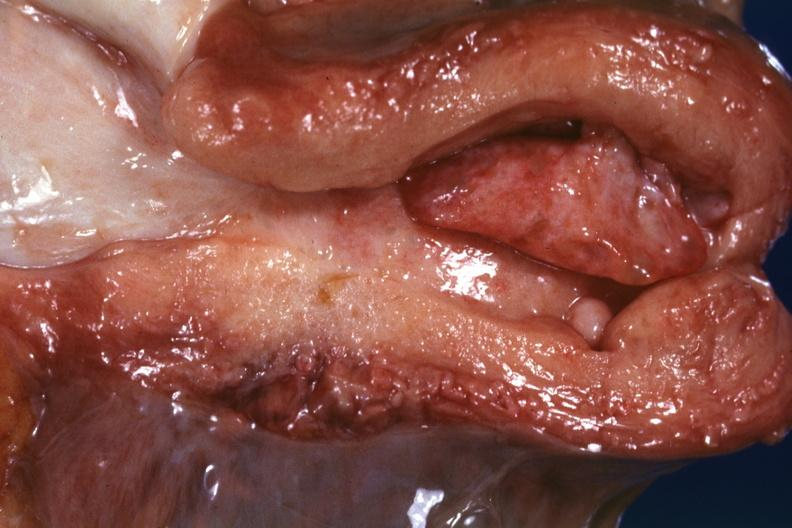s uterus present?
Answer the question using a single word or phrase. Yes 